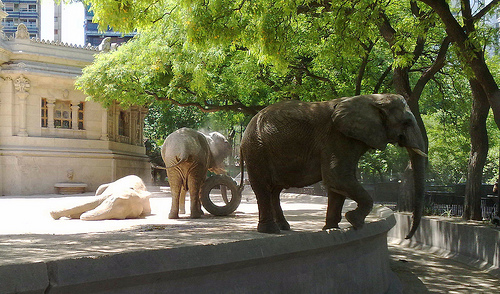How many elephants are lying down? 1 